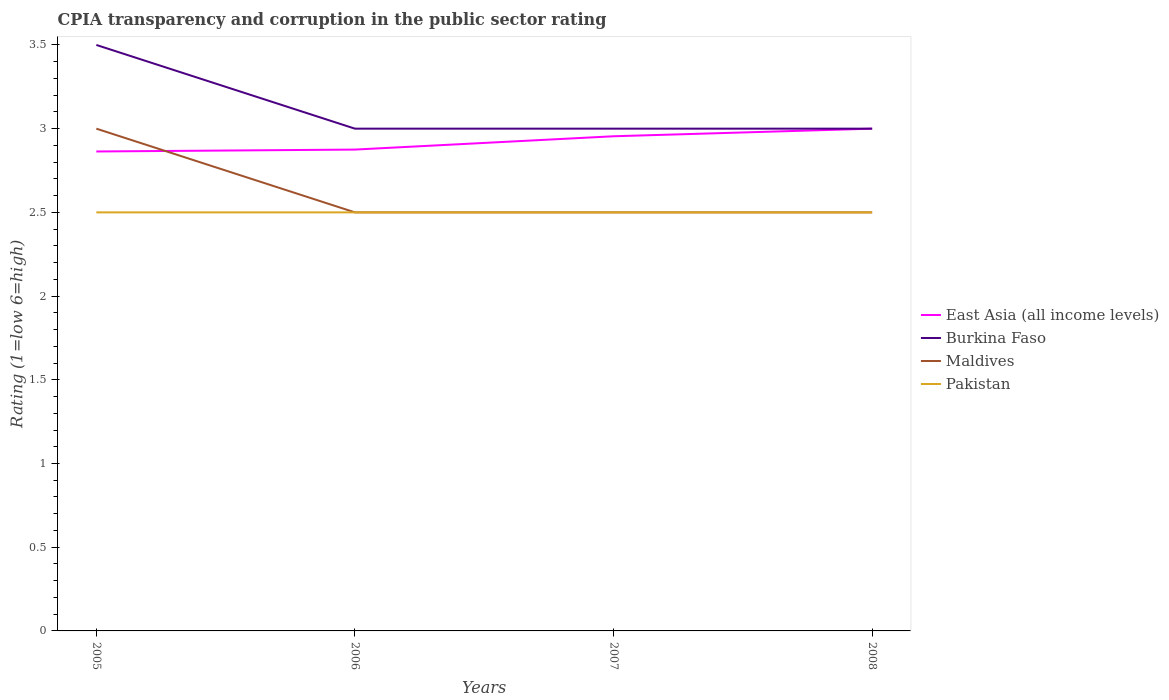How many different coloured lines are there?
Offer a terse response. 4. Is the number of lines equal to the number of legend labels?
Keep it short and to the point. Yes. Across all years, what is the maximum CPIA rating in East Asia (all income levels)?
Make the answer very short. 2.86. In which year was the CPIA rating in Burkina Faso maximum?
Offer a terse response. 2006. What is the total CPIA rating in East Asia (all income levels) in the graph?
Your answer should be compact. -0.09. Is the CPIA rating in Pakistan strictly greater than the CPIA rating in Burkina Faso over the years?
Offer a terse response. Yes. How many lines are there?
Ensure brevity in your answer.  4. What is the difference between two consecutive major ticks on the Y-axis?
Provide a short and direct response. 0.5. Does the graph contain any zero values?
Provide a short and direct response. No. How are the legend labels stacked?
Your answer should be very brief. Vertical. What is the title of the graph?
Give a very brief answer. CPIA transparency and corruption in the public sector rating. What is the label or title of the X-axis?
Your answer should be compact. Years. What is the Rating (1=low 6=high) in East Asia (all income levels) in 2005?
Provide a succinct answer. 2.86. What is the Rating (1=low 6=high) of East Asia (all income levels) in 2006?
Your response must be concise. 2.88. What is the Rating (1=low 6=high) of Maldives in 2006?
Ensure brevity in your answer.  2.5. What is the Rating (1=low 6=high) of Pakistan in 2006?
Your answer should be compact. 2.5. What is the Rating (1=low 6=high) in East Asia (all income levels) in 2007?
Your answer should be compact. 2.95. What is the Rating (1=low 6=high) of Burkina Faso in 2007?
Provide a succinct answer. 3. What is the Rating (1=low 6=high) of Maldives in 2007?
Provide a succinct answer. 2.5. What is the Rating (1=low 6=high) of Pakistan in 2007?
Offer a very short reply. 2.5. What is the Rating (1=low 6=high) in Burkina Faso in 2008?
Offer a terse response. 3. Across all years, what is the maximum Rating (1=low 6=high) in Burkina Faso?
Offer a terse response. 3.5. Across all years, what is the maximum Rating (1=low 6=high) of Pakistan?
Make the answer very short. 2.5. Across all years, what is the minimum Rating (1=low 6=high) in East Asia (all income levels)?
Give a very brief answer. 2.86. Across all years, what is the minimum Rating (1=low 6=high) of Burkina Faso?
Provide a short and direct response. 3. Across all years, what is the minimum Rating (1=low 6=high) of Maldives?
Provide a short and direct response. 2.5. Across all years, what is the minimum Rating (1=low 6=high) of Pakistan?
Ensure brevity in your answer.  2.5. What is the total Rating (1=low 6=high) in East Asia (all income levels) in the graph?
Your answer should be compact. 11.69. What is the total Rating (1=low 6=high) of Burkina Faso in the graph?
Give a very brief answer. 12.5. What is the total Rating (1=low 6=high) of Maldives in the graph?
Your answer should be compact. 10.5. What is the total Rating (1=low 6=high) in Pakistan in the graph?
Ensure brevity in your answer.  10. What is the difference between the Rating (1=low 6=high) in East Asia (all income levels) in 2005 and that in 2006?
Give a very brief answer. -0.01. What is the difference between the Rating (1=low 6=high) in Burkina Faso in 2005 and that in 2006?
Offer a terse response. 0.5. What is the difference between the Rating (1=low 6=high) in Pakistan in 2005 and that in 2006?
Provide a short and direct response. 0. What is the difference between the Rating (1=low 6=high) of East Asia (all income levels) in 2005 and that in 2007?
Your answer should be compact. -0.09. What is the difference between the Rating (1=low 6=high) of Burkina Faso in 2005 and that in 2007?
Give a very brief answer. 0.5. What is the difference between the Rating (1=low 6=high) of Maldives in 2005 and that in 2007?
Offer a terse response. 0.5. What is the difference between the Rating (1=low 6=high) in Pakistan in 2005 and that in 2007?
Your answer should be very brief. 0. What is the difference between the Rating (1=low 6=high) in East Asia (all income levels) in 2005 and that in 2008?
Your answer should be very brief. -0.14. What is the difference between the Rating (1=low 6=high) in East Asia (all income levels) in 2006 and that in 2007?
Your answer should be compact. -0.08. What is the difference between the Rating (1=low 6=high) of Pakistan in 2006 and that in 2007?
Provide a succinct answer. 0. What is the difference between the Rating (1=low 6=high) in East Asia (all income levels) in 2006 and that in 2008?
Provide a short and direct response. -0.12. What is the difference between the Rating (1=low 6=high) of Burkina Faso in 2006 and that in 2008?
Provide a succinct answer. 0. What is the difference between the Rating (1=low 6=high) in Pakistan in 2006 and that in 2008?
Offer a very short reply. 0. What is the difference between the Rating (1=low 6=high) in East Asia (all income levels) in 2007 and that in 2008?
Give a very brief answer. -0.05. What is the difference between the Rating (1=low 6=high) in Maldives in 2007 and that in 2008?
Ensure brevity in your answer.  0. What is the difference between the Rating (1=low 6=high) in Pakistan in 2007 and that in 2008?
Offer a terse response. 0. What is the difference between the Rating (1=low 6=high) of East Asia (all income levels) in 2005 and the Rating (1=low 6=high) of Burkina Faso in 2006?
Offer a terse response. -0.14. What is the difference between the Rating (1=low 6=high) in East Asia (all income levels) in 2005 and the Rating (1=low 6=high) in Maldives in 2006?
Your answer should be very brief. 0.36. What is the difference between the Rating (1=low 6=high) of East Asia (all income levels) in 2005 and the Rating (1=low 6=high) of Pakistan in 2006?
Provide a short and direct response. 0.36. What is the difference between the Rating (1=low 6=high) of Burkina Faso in 2005 and the Rating (1=low 6=high) of Maldives in 2006?
Keep it short and to the point. 1. What is the difference between the Rating (1=low 6=high) of Burkina Faso in 2005 and the Rating (1=low 6=high) of Pakistan in 2006?
Ensure brevity in your answer.  1. What is the difference between the Rating (1=low 6=high) in East Asia (all income levels) in 2005 and the Rating (1=low 6=high) in Burkina Faso in 2007?
Keep it short and to the point. -0.14. What is the difference between the Rating (1=low 6=high) of East Asia (all income levels) in 2005 and the Rating (1=low 6=high) of Maldives in 2007?
Your answer should be very brief. 0.36. What is the difference between the Rating (1=low 6=high) of East Asia (all income levels) in 2005 and the Rating (1=low 6=high) of Pakistan in 2007?
Give a very brief answer. 0.36. What is the difference between the Rating (1=low 6=high) in Burkina Faso in 2005 and the Rating (1=low 6=high) in Maldives in 2007?
Your response must be concise. 1. What is the difference between the Rating (1=low 6=high) of Maldives in 2005 and the Rating (1=low 6=high) of Pakistan in 2007?
Ensure brevity in your answer.  0.5. What is the difference between the Rating (1=low 6=high) of East Asia (all income levels) in 2005 and the Rating (1=low 6=high) of Burkina Faso in 2008?
Make the answer very short. -0.14. What is the difference between the Rating (1=low 6=high) in East Asia (all income levels) in 2005 and the Rating (1=low 6=high) in Maldives in 2008?
Provide a short and direct response. 0.36. What is the difference between the Rating (1=low 6=high) of East Asia (all income levels) in 2005 and the Rating (1=low 6=high) of Pakistan in 2008?
Provide a short and direct response. 0.36. What is the difference between the Rating (1=low 6=high) in Burkina Faso in 2005 and the Rating (1=low 6=high) in Maldives in 2008?
Your answer should be compact. 1. What is the difference between the Rating (1=low 6=high) of Maldives in 2005 and the Rating (1=low 6=high) of Pakistan in 2008?
Provide a succinct answer. 0.5. What is the difference between the Rating (1=low 6=high) in East Asia (all income levels) in 2006 and the Rating (1=low 6=high) in Burkina Faso in 2007?
Give a very brief answer. -0.12. What is the difference between the Rating (1=low 6=high) of East Asia (all income levels) in 2006 and the Rating (1=low 6=high) of Maldives in 2007?
Your response must be concise. 0.38. What is the difference between the Rating (1=low 6=high) of East Asia (all income levels) in 2006 and the Rating (1=low 6=high) of Pakistan in 2007?
Ensure brevity in your answer.  0.38. What is the difference between the Rating (1=low 6=high) in Burkina Faso in 2006 and the Rating (1=low 6=high) in Maldives in 2007?
Ensure brevity in your answer.  0.5. What is the difference between the Rating (1=low 6=high) of Maldives in 2006 and the Rating (1=low 6=high) of Pakistan in 2007?
Ensure brevity in your answer.  0. What is the difference between the Rating (1=low 6=high) of East Asia (all income levels) in 2006 and the Rating (1=low 6=high) of Burkina Faso in 2008?
Provide a short and direct response. -0.12. What is the difference between the Rating (1=low 6=high) in Burkina Faso in 2006 and the Rating (1=low 6=high) in Maldives in 2008?
Offer a terse response. 0.5. What is the difference between the Rating (1=low 6=high) in Maldives in 2006 and the Rating (1=low 6=high) in Pakistan in 2008?
Keep it short and to the point. 0. What is the difference between the Rating (1=low 6=high) in East Asia (all income levels) in 2007 and the Rating (1=low 6=high) in Burkina Faso in 2008?
Give a very brief answer. -0.05. What is the difference between the Rating (1=low 6=high) of East Asia (all income levels) in 2007 and the Rating (1=low 6=high) of Maldives in 2008?
Provide a short and direct response. 0.45. What is the difference between the Rating (1=low 6=high) in East Asia (all income levels) in 2007 and the Rating (1=low 6=high) in Pakistan in 2008?
Your answer should be compact. 0.45. What is the difference between the Rating (1=low 6=high) in Burkina Faso in 2007 and the Rating (1=low 6=high) in Pakistan in 2008?
Make the answer very short. 0.5. What is the difference between the Rating (1=low 6=high) in Maldives in 2007 and the Rating (1=low 6=high) in Pakistan in 2008?
Your answer should be compact. 0. What is the average Rating (1=low 6=high) in East Asia (all income levels) per year?
Give a very brief answer. 2.92. What is the average Rating (1=low 6=high) of Burkina Faso per year?
Your answer should be compact. 3.12. What is the average Rating (1=low 6=high) in Maldives per year?
Offer a terse response. 2.62. What is the average Rating (1=low 6=high) of Pakistan per year?
Make the answer very short. 2.5. In the year 2005, what is the difference between the Rating (1=low 6=high) in East Asia (all income levels) and Rating (1=low 6=high) in Burkina Faso?
Keep it short and to the point. -0.64. In the year 2005, what is the difference between the Rating (1=low 6=high) of East Asia (all income levels) and Rating (1=low 6=high) of Maldives?
Provide a succinct answer. -0.14. In the year 2005, what is the difference between the Rating (1=low 6=high) of East Asia (all income levels) and Rating (1=low 6=high) of Pakistan?
Ensure brevity in your answer.  0.36. In the year 2005, what is the difference between the Rating (1=low 6=high) in Burkina Faso and Rating (1=low 6=high) in Maldives?
Offer a very short reply. 0.5. In the year 2005, what is the difference between the Rating (1=low 6=high) in Burkina Faso and Rating (1=low 6=high) in Pakistan?
Ensure brevity in your answer.  1. In the year 2006, what is the difference between the Rating (1=low 6=high) in East Asia (all income levels) and Rating (1=low 6=high) in Burkina Faso?
Provide a succinct answer. -0.12. In the year 2006, what is the difference between the Rating (1=low 6=high) of Maldives and Rating (1=low 6=high) of Pakistan?
Offer a terse response. 0. In the year 2007, what is the difference between the Rating (1=low 6=high) of East Asia (all income levels) and Rating (1=low 6=high) of Burkina Faso?
Provide a short and direct response. -0.05. In the year 2007, what is the difference between the Rating (1=low 6=high) in East Asia (all income levels) and Rating (1=low 6=high) in Maldives?
Ensure brevity in your answer.  0.45. In the year 2007, what is the difference between the Rating (1=low 6=high) of East Asia (all income levels) and Rating (1=low 6=high) of Pakistan?
Ensure brevity in your answer.  0.45. In the year 2007, what is the difference between the Rating (1=low 6=high) of Burkina Faso and Rating (1=low 6=high) of Pakistan?
Offer a terse response. 0.5. In the year 2008, what is the difference between the Rating (1=low 6=high) in East Asia (all income levels) and Rating (1=low 6=high) in Maldives?
Offer a terse response. 0.5. In the year 2008, what is the difference between the Rating (1=low 6=high) in Burkina Faso and Rating (1=low 6=high) in Pakistan?
Ensure brevity in your answer.  0.5. In the year 2008, what is the difference between the Rating (1=low 6=high) in Maldives and Rating (1=low 6=high) in Pakistan?
Provide a short and direct response. 0. What is the ratio of the Rating (1=low 6=high) in Pakistan in 2005 to that in 2006?
Your response must be concise. 1. What is the ratio of the Rating (1=low 6=high) in East Asia (all income levels) in 2005 to that in 2007?
Provide a succinct answer. 0.97. What is the ratio of the Rating (1=low 6=high) in East Asia (all income levels) in 2005 to that in 2008?
Your answer should be very brief. 0.95. What is the ratio of the Rating (1=low 6=high) of East Asia (all income levels) in 2006 to that in 2007?
Your response must be concise. 0.97. What is the ratio of the Rating (1=low 6=high) of Maldives in 2006 to that in 2007?
Make the answer very short. 1. What is the ratio of the Rating (1=low 6=high) in Pakistan in 2006 to that in 2007?
Make the answer very short. 1. What is the ratio of the Rating (1=low 6=high) in Maldives in 2006 to that in 2008?
Offer a very short reply. 1. What is the ratio of the Rating (1=low 6=high) of Pakistan in 2006 to that in 2008?
Provide a short and direct response. 1. What is the ratio of the Rating (1=low 6=high) in East Asia (all income levels) in 2007 to that in 2008?
Give a very brief answer. 0.98. What is the ratio of the Rating (1=low 6=high) in Burkina Faso in 2007 to that in 2008?
Provide a short and direct response. 1. What is the ratio of the Rating (1=low 6=high) of Pakistan in 2007 to that in 2008?
Give a very brief answer. 1. What is the difference between the highest and the second highest Rating (1=low 6=high) of East Asia (all income levels)?
Ensure brevity in your answer.  0.05. What is the difference between the highest and the second highest Rating (1=low 6=high) in Maldives?
Provide a short and direct response. 0.5. What is the difference between the highest and the second highest Rating (1=low 6=high) in Pakistan?
Offer a terse response. 0. What is the difference between the highest and the lowest Rating (1=low 6=high) in East Asia (all income levels)?
Provide a succinct answer. 0.14. What is the difference between the highest and the lowest Rating (1=low 6=high) in Burkina Faso?
Your answer should be very brief. 0.5. What is the difference between the highest and the lowest Rating (1=low 6=high) of Maldives?
Your answer should be compact. 0.5. What is the difference between the highest and the lowest Rating (1=low 6=high) of Pakistan?
Make the answer very short. 0. 